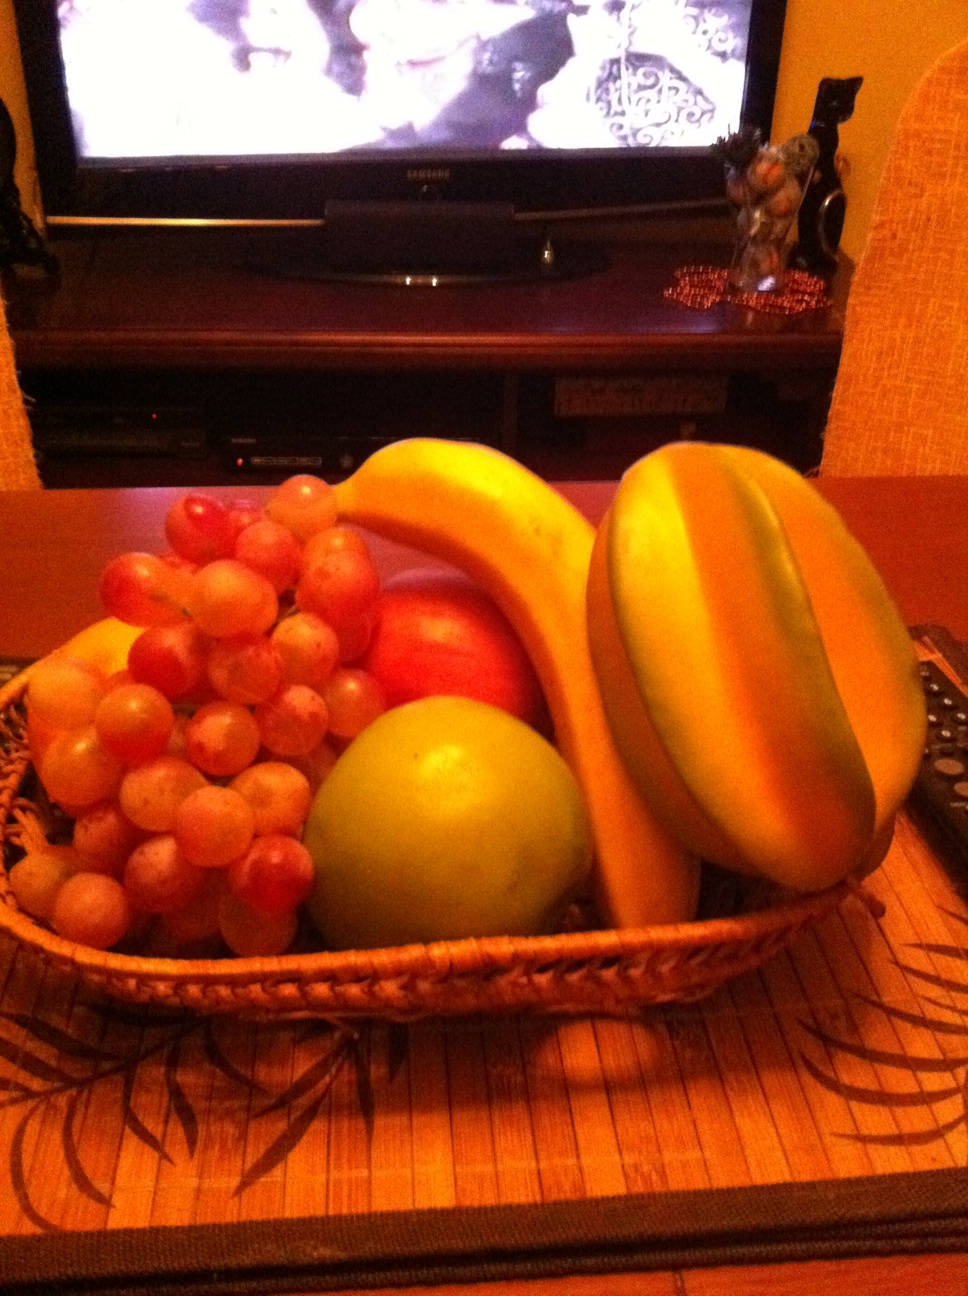What is this? The image depicts a vividly colorful fruit basket richly filled with bananas, what appears to be a large papaya, a mound of red and white grapes, a shiny red apple, and a sizable green apple, artfully arranged on a woven basket. This basket is placed on a textured placemat, on a wooden table, with the soft glow of a television screen subtly illuminating the background, creating a cozy, domestic atmosphere. 